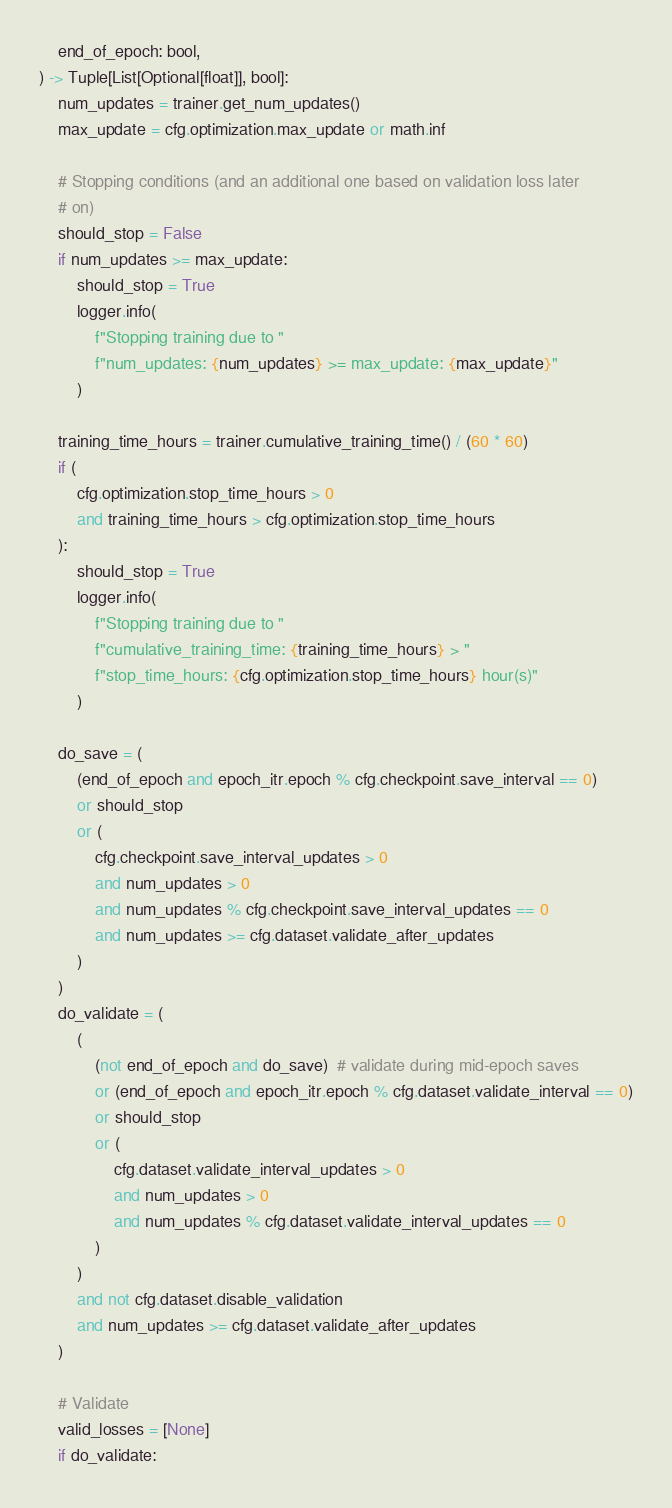Convert code to text. <code><loc_0><loc_0><loc_500><loc_500><_Python_>    end_of_epoch: bool,
) -> Tuple[List[Optional[float]], bool]:
    num_updates = trainer.get_num_updates()
    max_update = cfg.optimization.max_update or math.inf

    # Stopping conditions (and an additional one based on validation loss later
    # on)
    should_stop = False
    if num_updates >= max_update:
        should_stop = True
        logger.info(
            f"Stopping training due to "
            f"num_updates: {num_updates} >= max_update: {max_update}"
        )

    training_time_hours = trainer.cumulative_training_time() / (60 * 60)
    if (
        cfg.optimization.stop_time_hours > 0
        and training_time_hours > cfg.optimization.stop_time_hours
    ):
        should_stop = True
        logger.info(
            f"Stopping training due to "
            f"cumulative_training_time: {training_time_hours} > "
            f"stop_time_hours: {cfg.optimization.stop_time_hours} hour(s)"
        )

    do_save = (
        (end_of_epoch and epoch_itr.epoch % cfg.checkpoint.save_interval == 0)
        or should_stop
        or (
            cfg.checkpoint.save_interval_updates > 0
            and num_updates > 0
            and num_updates % cfg.checkpoint.save_interval_updates == 0
            and num_updates >= cfg.dataset.validate_after_updates
        )
    )
    do_validate = (
        (
            (not end_of_epoch and do_save)  # validate during mid-epoch saves
            or (end_of_epoch and epoch_itr.epoch % cfg.dataset.validate_interval == 0)
            or should_stop
            or (
                cfg.dataset.validate_interval_updates > 0
                and num_updates > 0
                and num_updates % cfg.dataset.validate_interval_updates == 0
            )
        )
        and not cfg.dataset.disable_validation
        and num_updates >= cfg.dataset.validate_after_updates
    )

    # Validate
    valid_losses = [None]
    if do_validate:</code> 